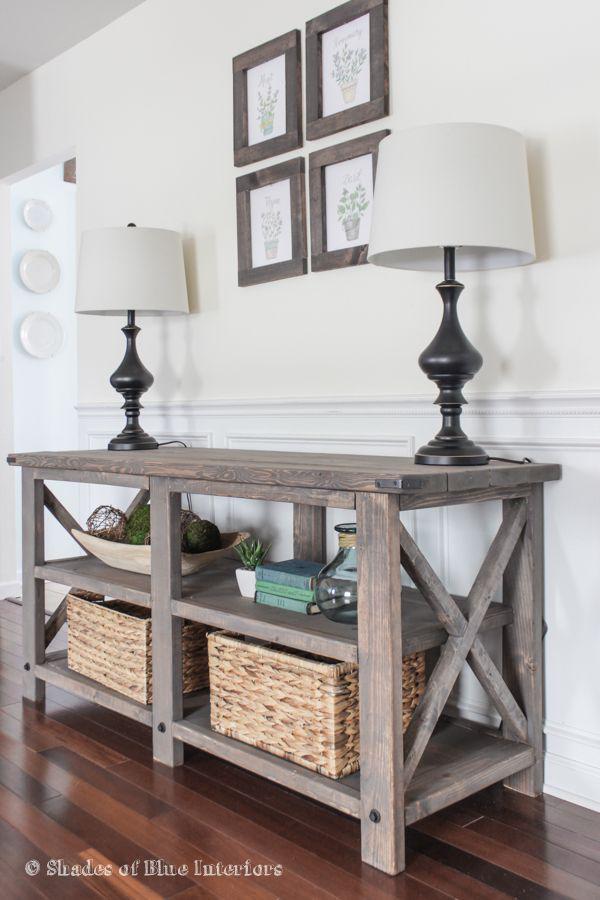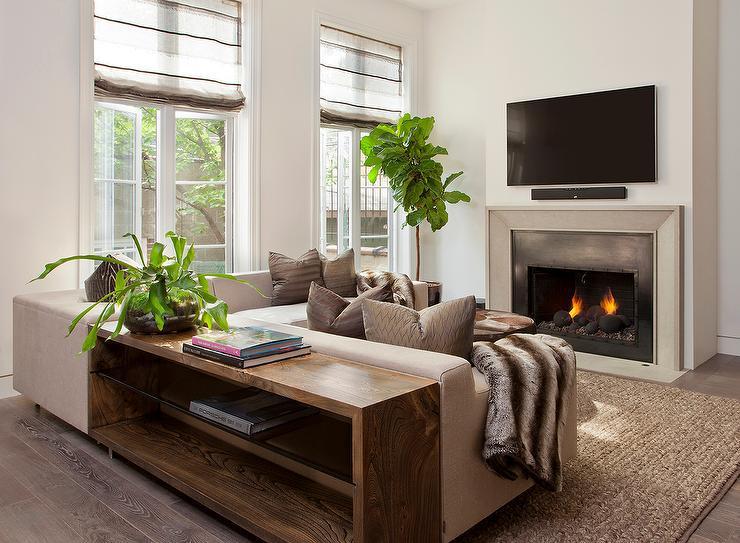The first image is the image on the left, the second image is the image on the right. Considering the images on both sides, is "A TV with a black screen is hanging on a white wall." valid? Answer yes or no. Yes. 